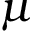<formula> <loc_0><loc_0><loc_500><loc_500>\mu</formula> 